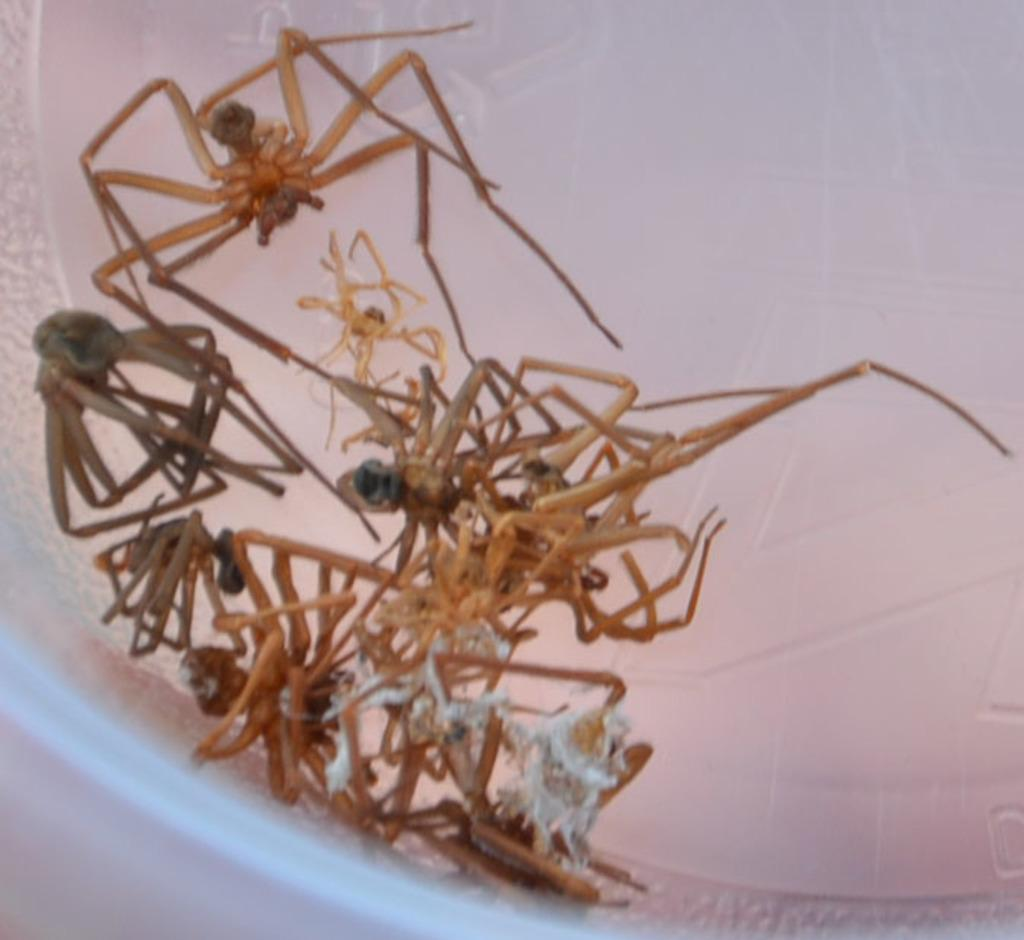What creatures are present in the image? There are spiders in the image. Where are the spiders located? The spiders are in a plastic container. What type of powder is being used to feed the spiders in the image? There is no powder or feeding activity depicted in the image; it simply shows spiders in a plastic container. 